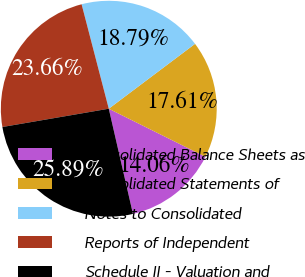<chart> <loc_0><loc_0><loc_500><loc_500><pie_chart><fcel>Consolidated Balance Sheets as<fcel>Consolidated Statements of<fcel>Notes to Consolidated<fcel>Reports of Independent<fcel>Schedule II - Valuation and<nl><fcel>14.06%<fcel>17.61%<fcel>18.79%<fcel>23.66%<fcel>25.89%<nl></chart> 